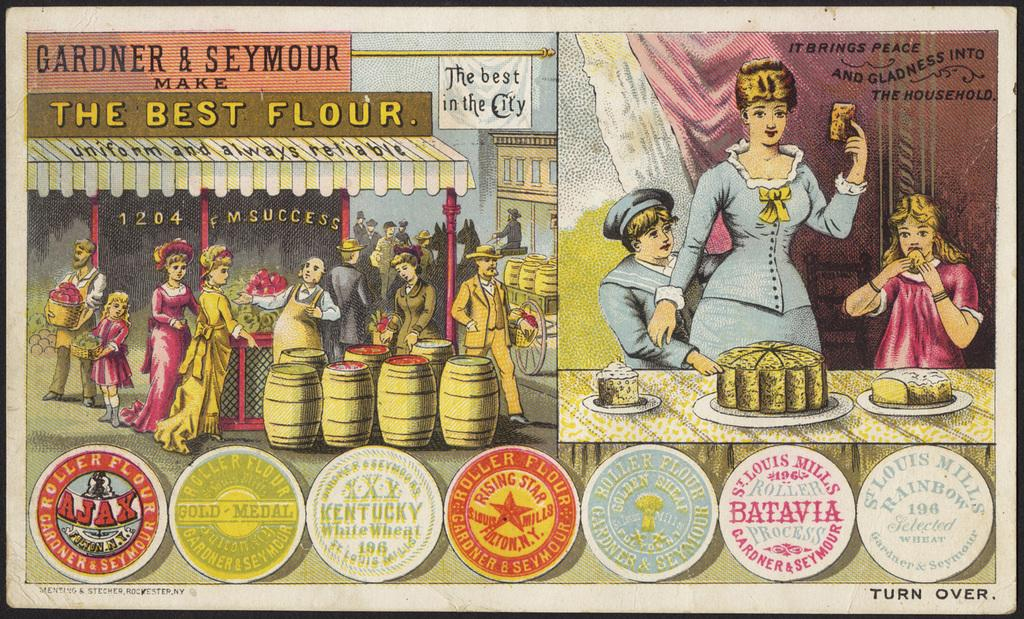<image>
Describe the image concisely. a lady in an image on a couple photos, one that has The Best Flour store 